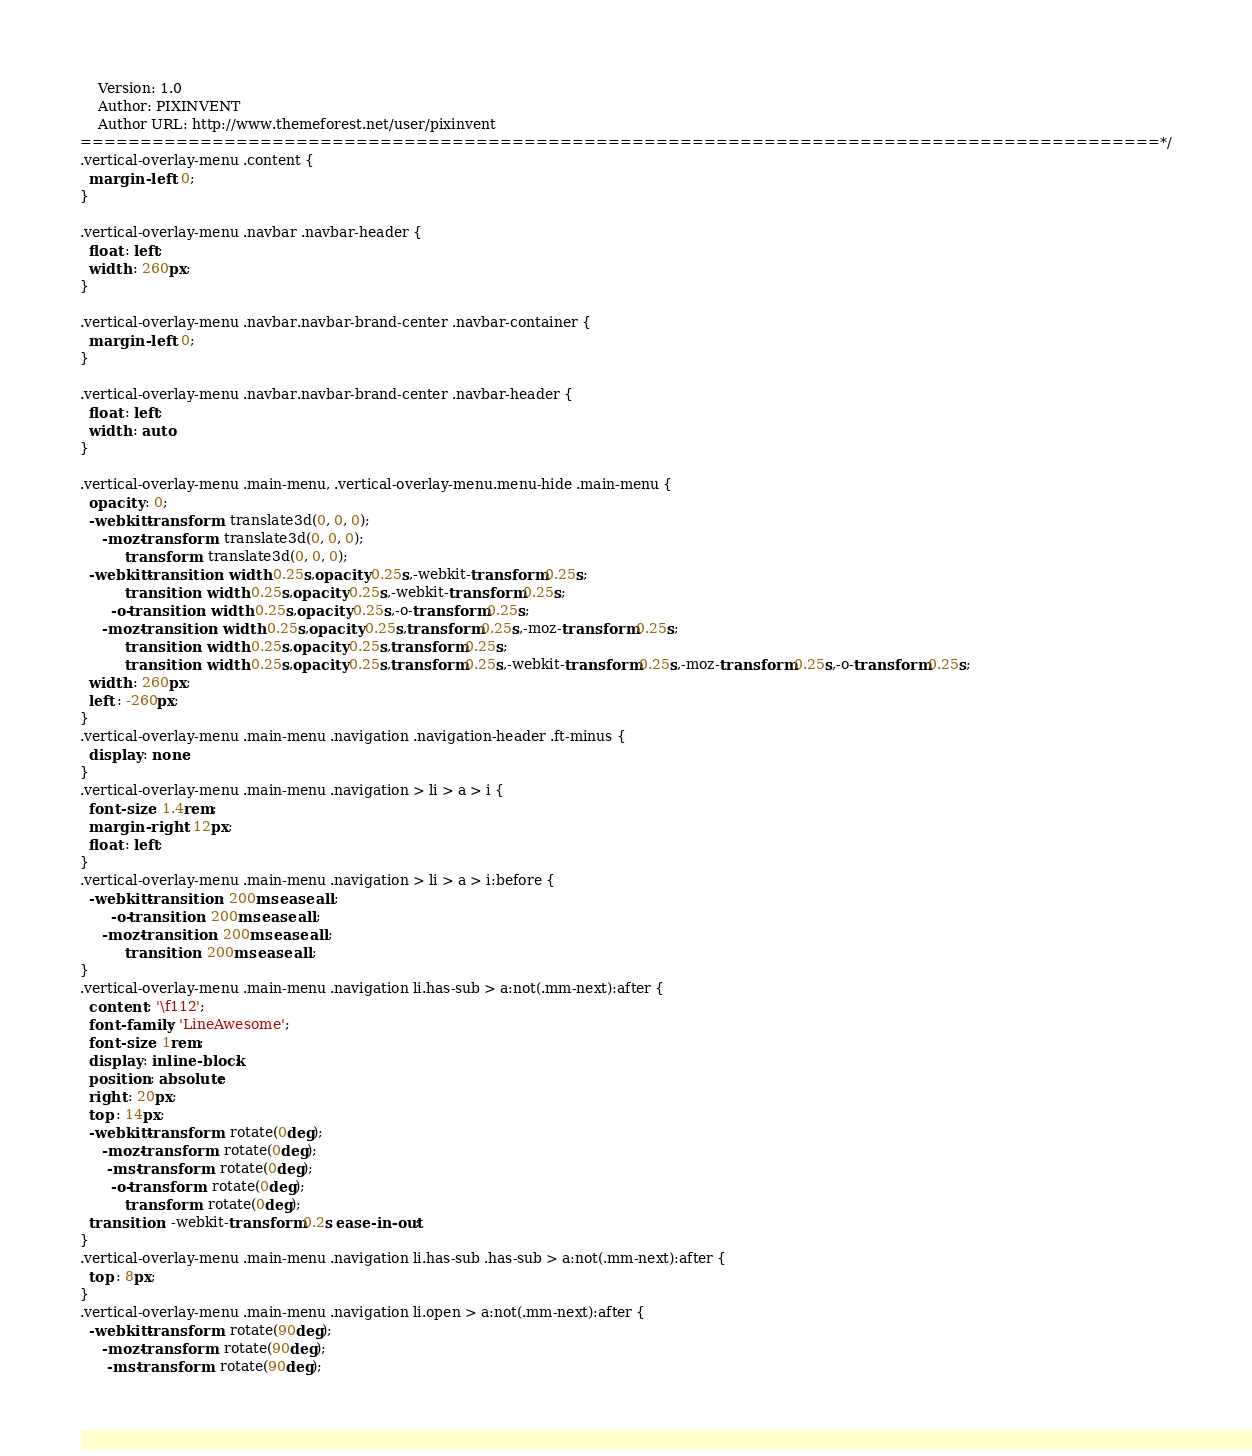<code> <loc_0><loc_0><loc_500><loc_500><_CSS_>	Version: 1.0
	Author: PIXINVENT
	Author URL: http://www.themeforest.net/user/pixinvent
==========================================================================================*/
.vertical-overlay-menu .content {
  margin-left : 0;
}

.vertical-overlay-menu .navbar .navbar-header {
  float : left;
  width : 260px;
}

.vertical-overlay-menu .navbar.navbar-brand-center .navbar-container {
  margin-left : 0;
}

.vertical-overlay-menu .navbar.navbar-brand-center .navbar-header {
  float : left;
  width : auto;
}

.vertical-overlay-menu .main-menu, .vertical-overlay-menu.menu-hide .main-menu {
  opacity : 0;
  -webkit-transform : translate3d(0, 0, 0);
     -moz-transform : translate3d(0, 0, 0);
          transform : translate3d(0, 0, 0);
  -webkit-transition : width 0.25s,opacity 0.25s,-webkit-transform 0.25s;
          transition : width 0.25s,opacity 0.25s,-webkit-transform 0.25s;
       -o-transition : width 0.25s,opacity 0.25s,-o-transform 0.25s;
     -moz-transition : width 0.25s,opacity 0.25s,transform 0.25s,-moz-transform 0.25s;
          transition : width 0.25s,opacity 0.25s,transform 0.25s;
          transition : width 0.25s,opacity 0.25s,transform 0.25s,-webkit-transform 0.25s,-moz-transform 0.25s,-o-transform 0.25s;
  width : 260px;
  left : -260px;
}
.vertical-overlay-menu .main-menu .navigation .navigation-header .ft-minus {
  display : none;
}
.vertical-overlay-menu .main-menu .navigation > li > a > i {
  font-size : 1.4rem;
  margin-right : 12px;
  float : left;
}
.vertical-overlay-menu .main-menu .navigation > li > a > i:before {
  -webkit-transition : 200ms ease all;
       -o-transition : 200ms ease all;
     -moz-transition : 200ms ease all;
          transition : 200ms ease all;
}
.vertical-overlay-menu .main-menu .navigation li.has-sub > a:not(.mm-next):after {
  content : '\f112';
  font-family : 'LineAwesome';
  font-size : 1rem;
  display : inline-block;
  position : absolute;
  right : 20px;
  top : 14px;
  -webkit-transform : rotate(0deg);
     -moz-transform : rotate(0deg);
      -ms-transform : rotate(0deg);
       -o-transform : rotate(0deg);
          transform : rotate(0deg);
  transition : -webkit-transform 0.2s ease-in-out;
}
.vertical-overlay-menu .main-menu .navigation li.has-sub .has-sub > a:not(.mm-next):after {
  top : 8px;
}
.vertical-overlay-menu .main-menu .navigation li.open > a:not(.mm-next):after {
  -webkit-transform : rotate(90deg);
     -moz-transform : rotate(90deg);
      -ms-transform : rotate(90deg);</code> 